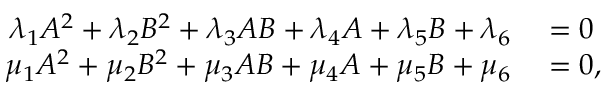<formula> <loc_0><loc_0><loc_500><loc_500>\begin{array} { r l } { \lambda _ { 1 } A ^ { 2 } + \lambda _ { 2 } B ^ { 2 } + \lambda _ { 3 } A B + \lambda _ { 4 } A + \lambda _ { 5 } B + \lambda _ { 6 } } & = 0 } \\ { \mu _ { 1 } A ^ { 2 } + \mu _ { 2 } B ^ { 2 } + \mu _ { 3 } A B + \mu _ { 4 } A + \mu _ { 5 } B + \mu _ { 6 } } & = 0 , } \end{array}</formula> 